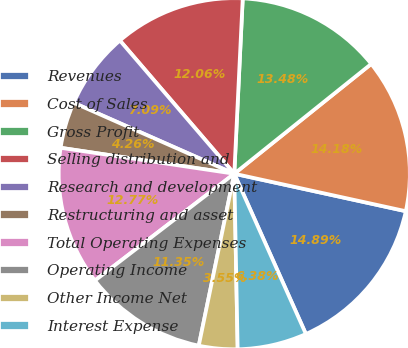<chart> <loc_0><loc_0><loc_500><loc_500><pie_chart><fcel>Revenues<fcel>Cost of Sales<fcel>Gross Profit<fcel>Selling distribution and<fcel>Research and development<fcel>Restructuring and asset<fcel>Total Operating Expenses<fcel>Operating Income<fcel>Other Income Net<fcel>Interest Expense<nl><fcel>14.89%<fcel>14.18%<fcel>13.48%<fcel>12.06%<fcel>7.09%<fcel>4.26%<fcel>12.77%<fcel>11.35%<fcel>3.55%<fcel>6.38%<nl></chart> 